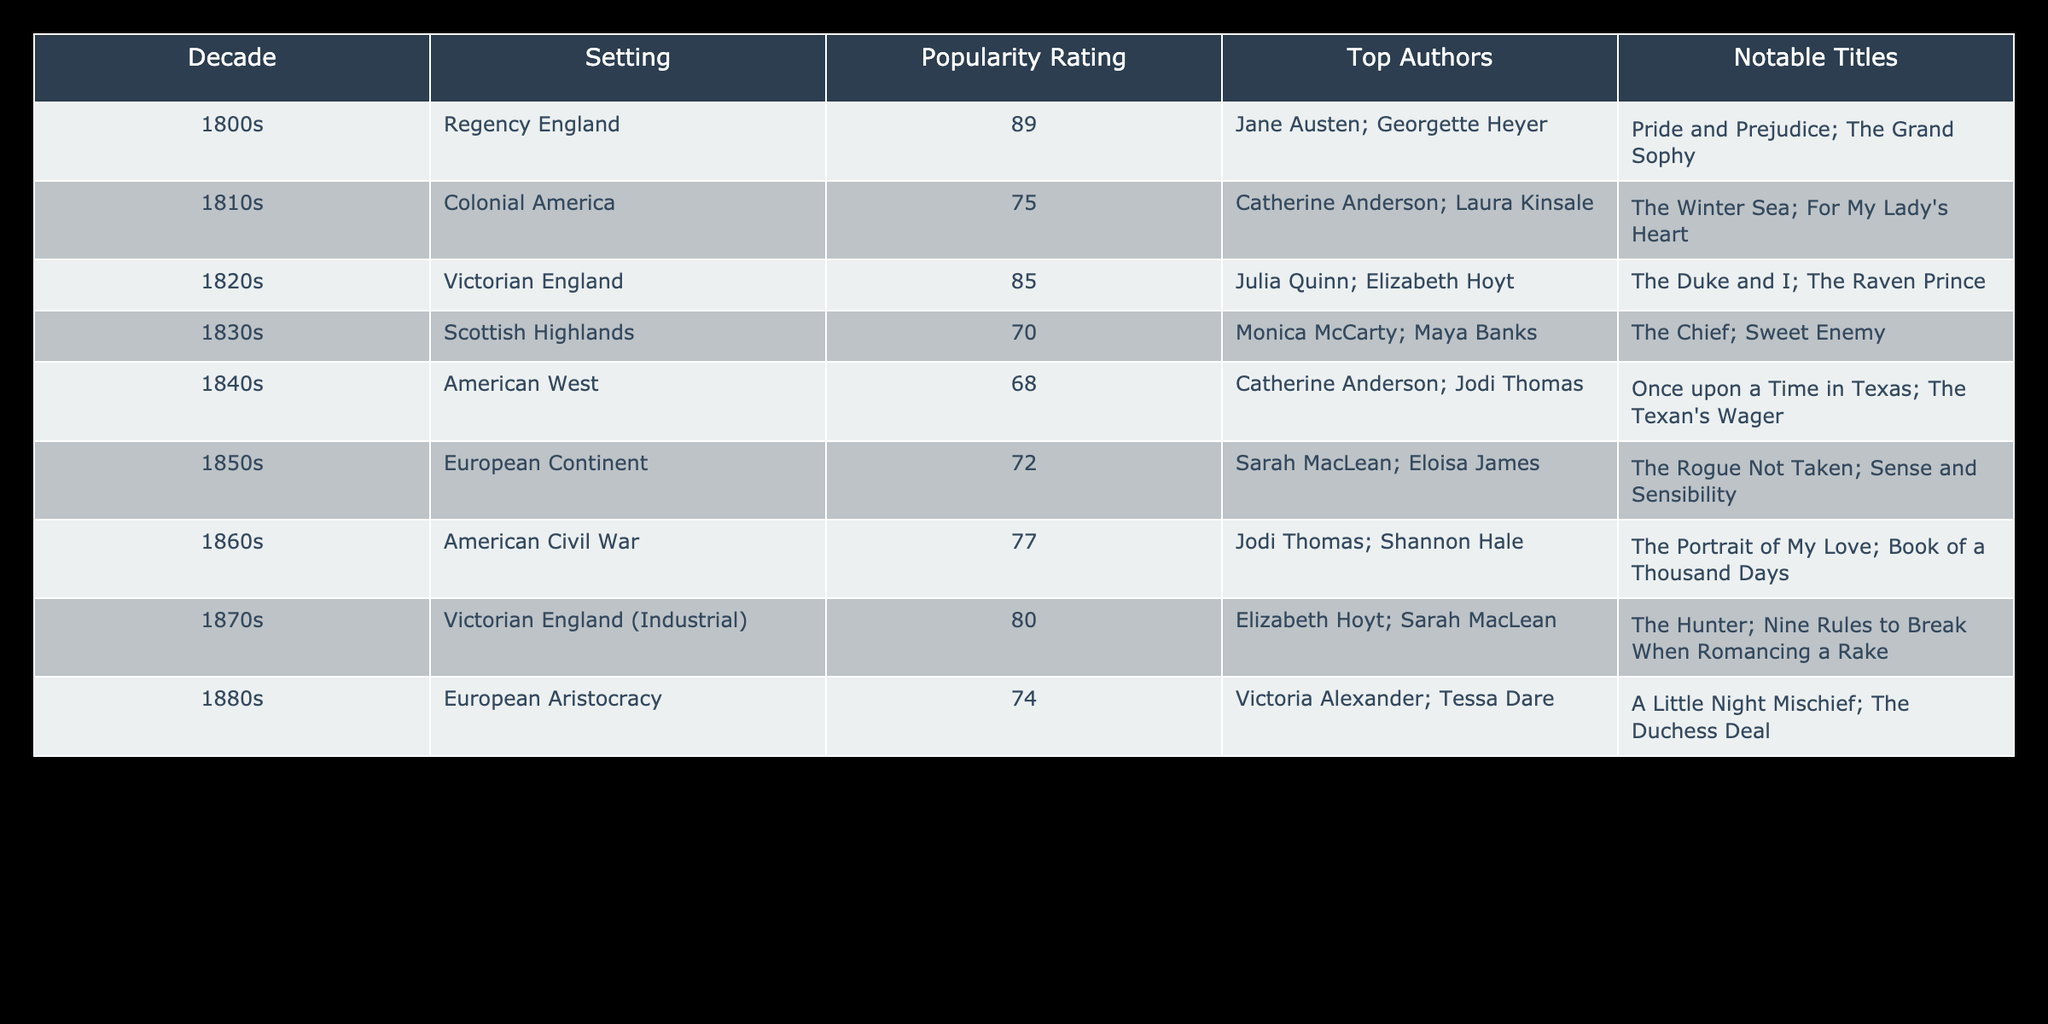What is the popularity rating for Victorian England in the 1820s? The table shows the popularity rating for Victorian England is listed under the 1820s as 85.
Answer: 85 Which decade has the highest popularity rating? The highest popularity rating can be found by looking through the popularity ratings in the table. The highest value is 89 for Regency England in the 1800s.
Answer: 1800s How many settings have a popularity rating above 75? To find the number of settings above 75, we look at the ratings: 89 (1800s), 85 (1820s), and 77 (1860s). That gives us a total of 3 settings.
Answer: 3 Is there a notable title listed for the American Civil War setting? The table explicitly lists "The Portrait of My Love" and "Book of a Thousand Days" as notable titles under the American Civil War setting for the 1860s, confirming the presence of notable titles.
Answer: Yes What is the average popularity rating for the settings listed in the 1800s and 1870s? Calculate the average: (89 from the 1800s + 80 from the 1870s) = 169, and divide by 2, which gives 169 / 2 = 84.5.
Answer: 84.5 Which decade features the lowest popularity rating among American settings? The lowest rating among the American settings is 68 for the American West in the 1840s. This is confirmed by checking all American settings in the table.
Answer: 1840s Are there notable titles listed for Colonial America? The table indicates that "The Winter Sea" and "For My Lady's Heart" are notable titles for Colonial America in the 1810s, confirming that there are notable titles.
Answer: Yes What is the difference in popularity ratings between Victorian England in the 1820s and the American Civil War setting? The difference can be found by subtracting the American Civil War rating (77) from the Victorian England rating (85): 85 - 77 = 8.
Answer: 8 How many of the settings are related to European contexts, and what are their popularity ratings? The settings related to Europe are Victorian England (85), European Continent (72), and European Aristocracy (74). Thus, we have three settings, with respective ratings of 85, 72, and 74.
Answer: 3 settings; ratings: 85, 72, 74 